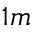Convert formula to latex. <formula><loc_0><loc_0><loc_500><loc_500>1 m</formula> 